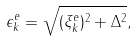<formula> <loc_0><loc_0><loc_500><loc_500>\epsilon _ { k } ^ { e } = \sqrt { ( \xi _ { k } ^ { e } ) ^ { 2 } + \Delta ^ { 2 } } ,</formula> 